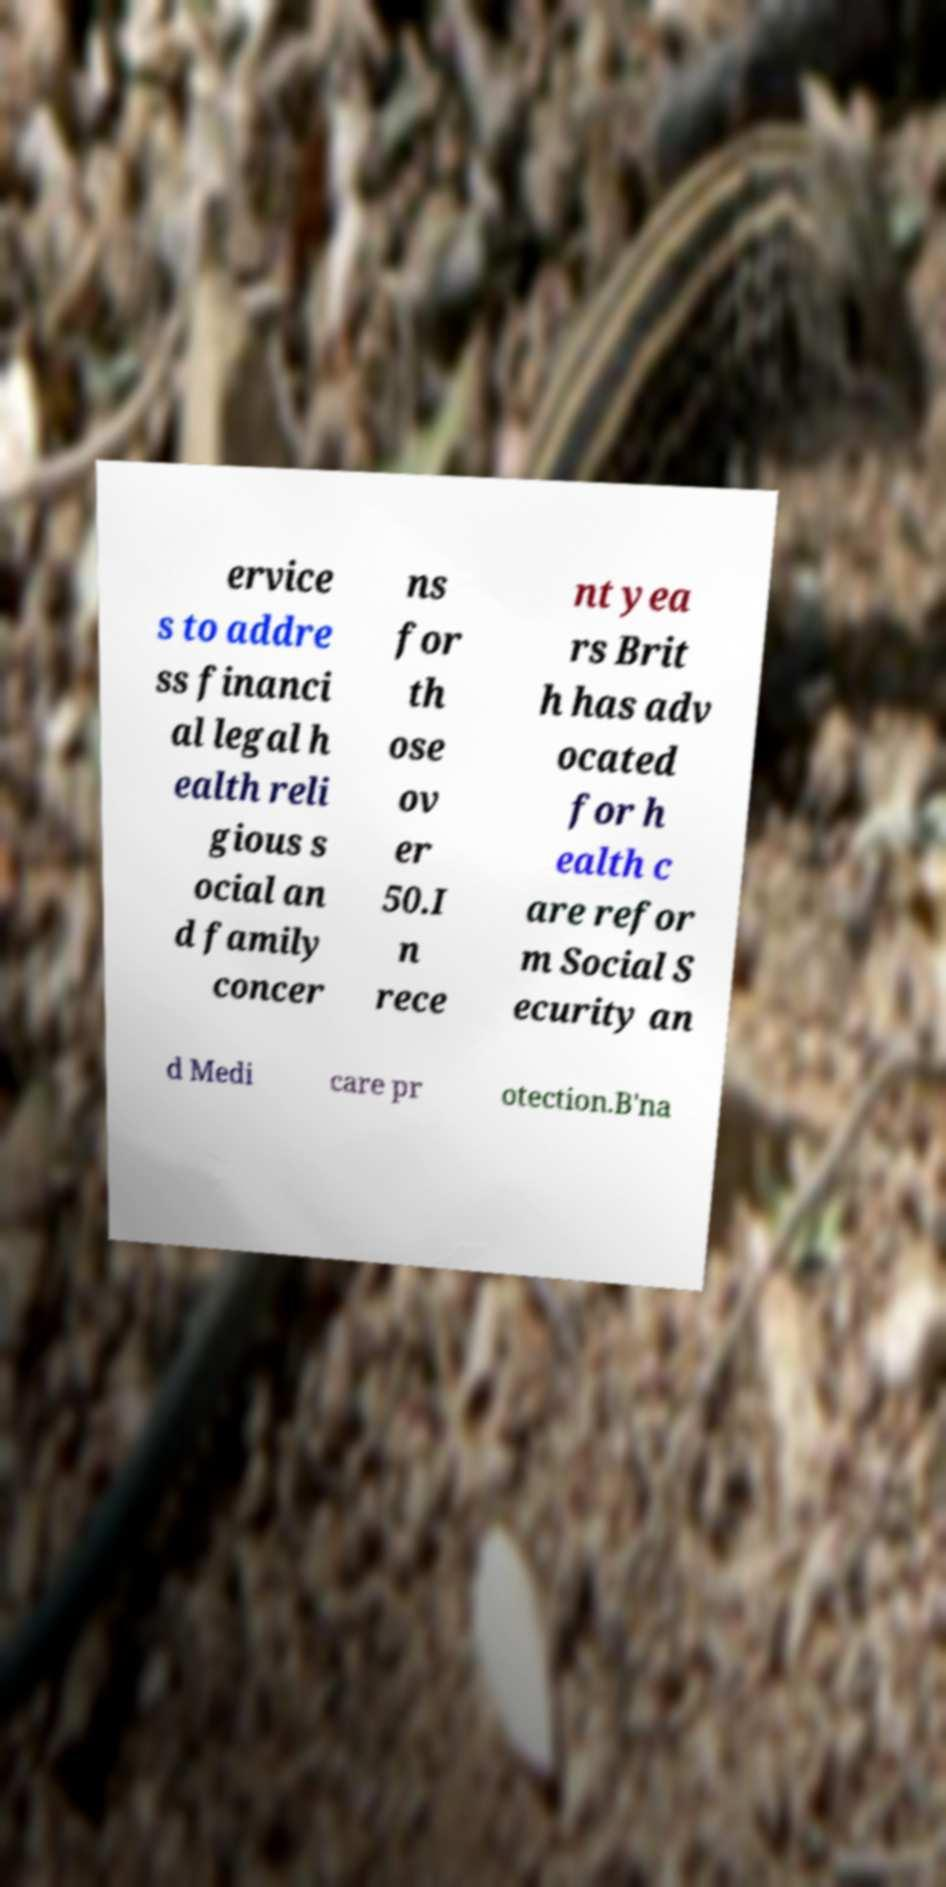Can you read and provide the text displayed in the image?This photo seems to have some interesting text. Can you extract and type it out for me? ervice s to addre ss financi al legal h ealth reli gious s ocial an d family concer ns for th ose ov er 50.I n rece nt yea rs Brit h has adv ocated for h ealth c are refor m Social S ecurity an d Medi care pr otection.B'na 